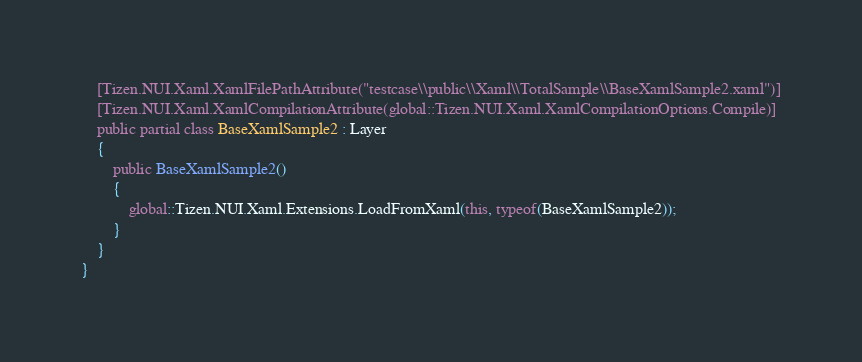<code> <loc_0><loc_0><loc_500><loc_500><_C#_>    [Tizen.NUI.Xaml.XamlFilePathAttribute("testcase\\public\\Xaml\\TotalSample\\BaseXamlSample2.xaml")]
    [Tizen.NUI.Xaml.XamlCompilationAttribute(global::Tizen.NUI.Xaml.XamlCompilationOptions.Compile)]
    public partial class BaseXamlSample2 : Layer
    {
        public BaseXamlSample2()
        {
            global::Tizen.NUI.Xaml.Extensions.LoadFromXaml(this, typeof(BaseXamlSample2));
        }
    }
}</code> 